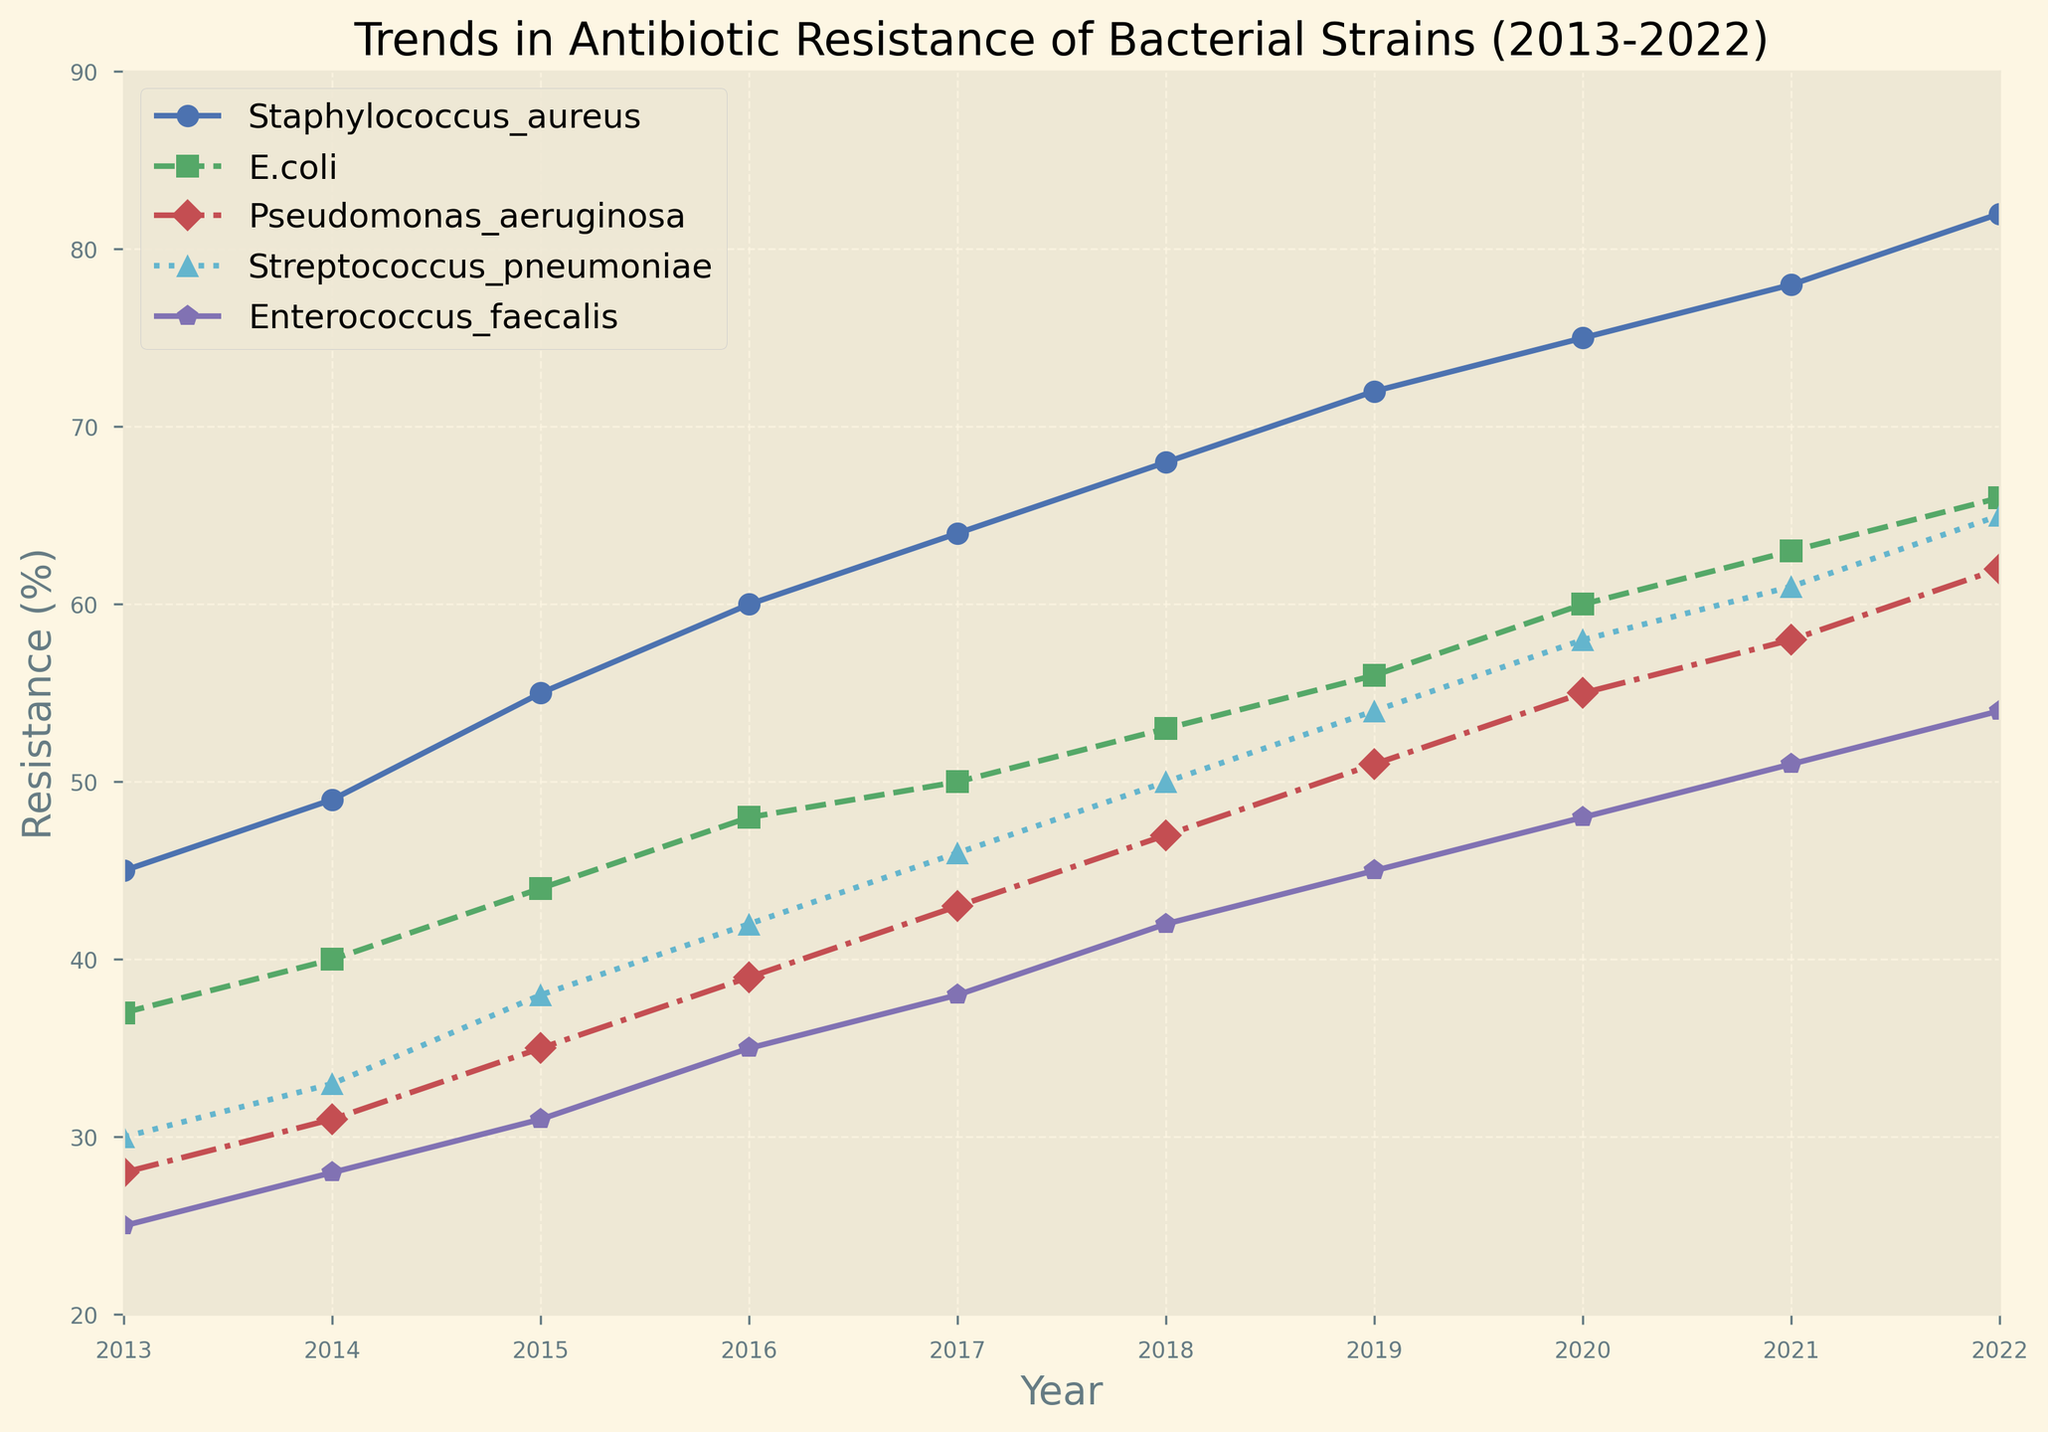What is the trend in antibiotic resistance for Staphylococcus aureus from 2013 to 2022? The resistance for Staphylococcus aureus increases every year from 45% in 2013 to 82% in 2022.
Answer: It increases Which bacterial strain shows the highest antibiotic resistance in 2022? By looking at the endpoints in 2022, Staphylococcus aureus has the highest resistance at 82%.
Answer: Staphylococcus aureus In which year did E. coli surpass 50% antibiotic resistance? By tracing the line for E.coli, it surpassed 50% in 2018.
Answer: 2018 What is the average antibiotic resistance for Pseudomonas aeruginosa across the decade? Calculate the average: (28 + 31 + 35 + 39 + 43 + 47 + 51 + 55 + 58 + 62)/10 = 41.9
Answer: 41.9 Compare the resistance trends of Enterococcus faecalis and Streptococcus pneumoniae over the decade. Which has a faster increase? Enterococcus faecalis increased from 25% to 54% (29%), whereas Streptococcus pneumoniae increased from 30% to 65% (35%). Streptococcus pneumoniae has a faster increase.
Answer: Streptococcus pneumoniae In which year do all bacterial strains show an antibiotic resistance of at least 40%? By examining the data points and the graph, 2016 is the first year where all strains are at or above 40%.
Answer: 2016 Which bacterial strains cross the 60% resistance mark, and in what year for each? Staphylococcus aureus in 2018, E. coli in 2021, and Streptococcus pneumoniae in 2022.
Answer: Staphylococcus aureus in 2018, E. coli in 2021, Streptococcus pneumoniae in 2022 How many bacterial strains had more than 50% resistance in 2019? Staphylococcus aureus (72%), E. coli (56%), and Streptococcus pneumoniae (54%) - a total of 3 strains.
Answer: 3 Which bacterial strain had the smallest increase in resistance from 2013 to 2022? Compare increases: {'Staphylococcus aureus': 37%, 'E. coli': 29%, 'Pseudomonas aeruginosa': 34%, 'Streptococcus pneumoniae': 35%, 'Enterococcus faecalis': 29%}. Both E.coli and Enterococcus faecalis had the smallest increase of 29%.
Answer: E. coli and Enterococcus faecalis 